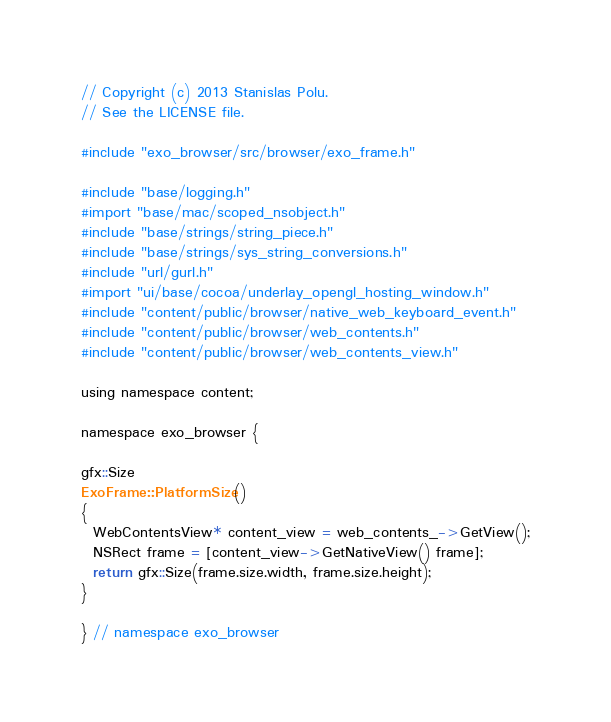Convert code to text. <code><loc_0><loc_0><loc_500><loc_500><_ObjectiveC_>// Copyright (c) 2013 Stanislas Polu.
// See the LICENSE file.

#include "exo_browser/src/browser/exo_frame.h"

#include "base/logging.h"
#import "base/mac/scoped_nsobject.h"
#include "base/strings/string_piece.h"
#include "base/strings/sys_string_conversions.h"
#include "url/gurl.h"
#import "ui/base/cocoa/underlay_opengl_hosting_window.h"
#include "content/public/browser/native_web_keyboard_event.h"
#include "content/public/browser/web_contents.h"
#include "content/public/browser/web_contents_view.h"

using namespace content;

namespace exo_browser {

gfx::Size
ExoFrame::PlatformSize()
{
  WebContentsView* content_view = web_contents_->GetView();
  NSRect frame = [content_view->GetNativeView() frame];
  return gfx::Size(frame.size.width, frame.size.height);
}

} // namespace exo_browser

</code> 